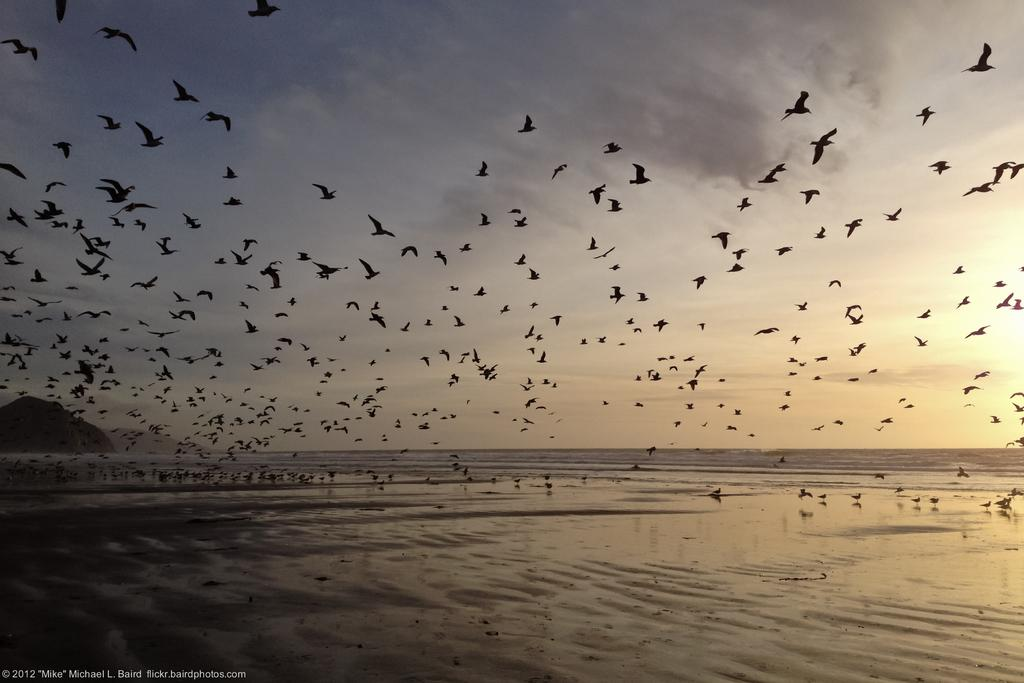What is happening with the birds in the image? There are birds flying in the sky and birds on the sand in the image. What can be seen on the left side of the image? There is a mountain on the left side of the image. What is visible in the background of the image? There is water visible in the background. What else is present in the sky besides the birds? There are clouds in the sky in the sky. What type of pet is lying on the bed in the image? There is no bed or pet present in the image; it features birds and a mountain. What selection of items can be seen in the image? The image primarily features birds, a mountain, water, and clouds, so there is no selection of items to choose from. 